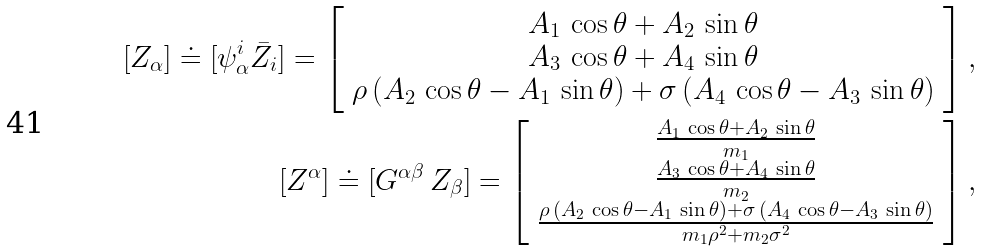Convert formula to latex. <formula><loc_0><loc_0><loc_500><loc_500>[ Z _ { \alpha } ] \doteq [ \psi ^ { i } _ { \alpha } \bar { Z } _ { i } ] = \left [ \begin{array} { c } A _ { 1 } \, \cos \theta + A _ { 2 } \, \sin \theta \\ A _ { 3 } \, \cos \theta + A _ { 4 } \, \sin \theta \\ \rho \, ( A _ { 2 } \, \cos \theta - A _ { 1 } \, \sin \theta ) + \sigma \, ( A _ { 4 } \, \cos \theta - A _ { 3 } \, \sin \theta ) \end{array} \right ] , \\ [ Z ^ { \alpha } ] \doteq [ G ^ { \alpha \beta } \, Z _ { \beta } ] = \left [ \begin{array} { c } \frac { A _ { 1 } \, \cos \theta + A _ { 2 } \, \sin \theta } { m _ { 1 } } \\ \frac { A _ { 3 } \, \cos \theta + A _ { 4 } \, \sin \theta } { m _ { 2 } } \\ \frac { \rho \, ( A _ { 2 } \, \cos \theta - A _ { 1 } \, \sin \theta ) + \sigma \, ( A _ { 4 } \, \cos \theta - A _ { 3 } \, \sin \theta ) } { m _ { 1 } \rho ^ { 2 } + m _ { 2 } \sigma ^ { 2 } } \\ \end{array} \right ] ,</formula> 